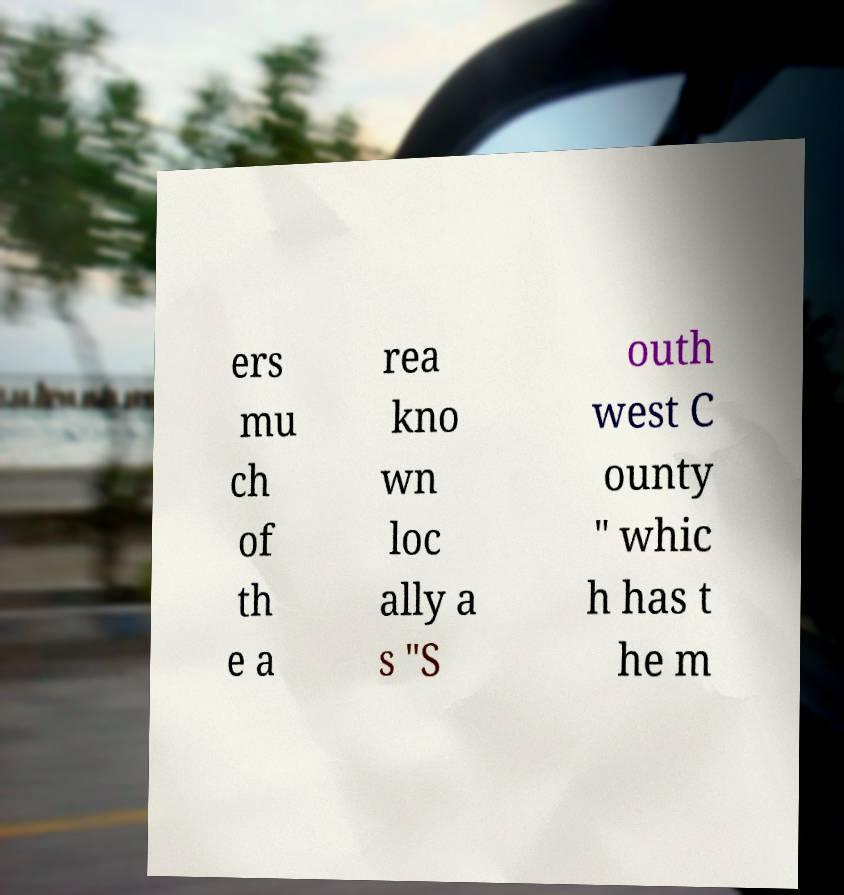There's text embedded in this image that I need extracted. Can you transcribe it verbatim? ers mu ch of th e a rea kno wn loc ally a s "S outh west C ounty " whic h has t he m 